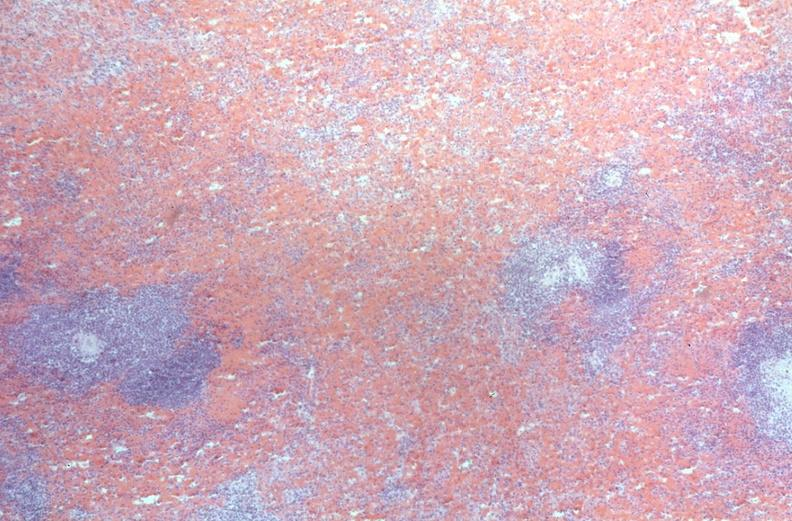does this image show spleen, congestion, congestive heart failure?
Answer the question using a single word or phrase. Yes 